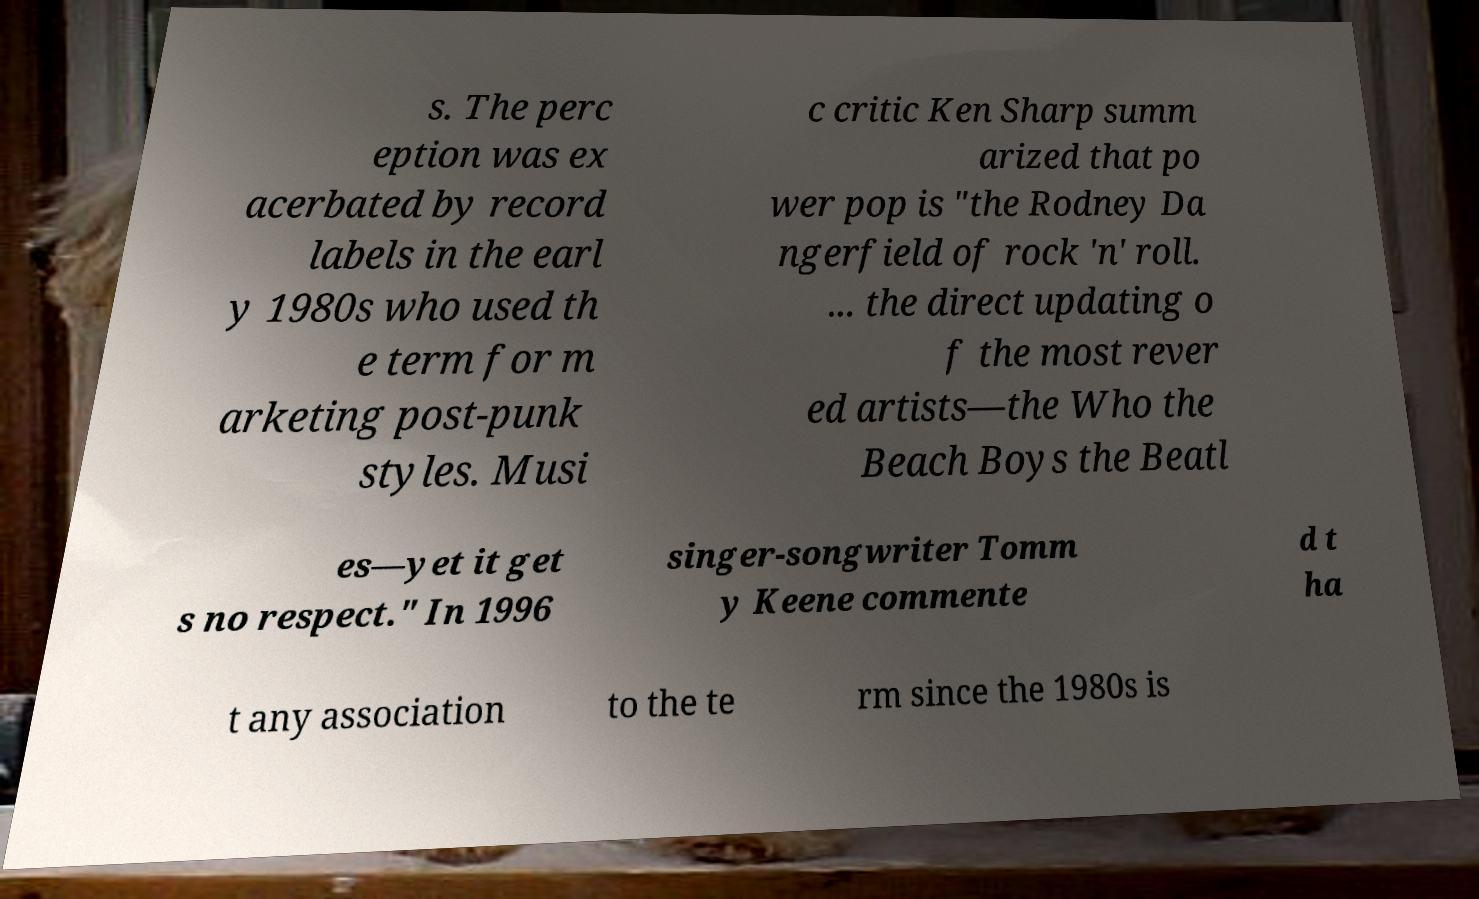For documentation purposes, I need the text within this image transcribed. Could you provide that? s. The perc eption was ex acerbated by record labels in the earl y 1980s who used th e term for m arketing post-punk styles. Musi c critic Ken Sharp summ arized that po wer pop is "the Rodney Da ngerfield of rock 'n' roll. ... the direct updating o f the most rever ed artists—the Who the Beach Boys the Beatl es—yet it get s no respect." In 1996 singer-songwriter Tomm y Keene commente d t ha t any association to the te rm since the 1980s is 